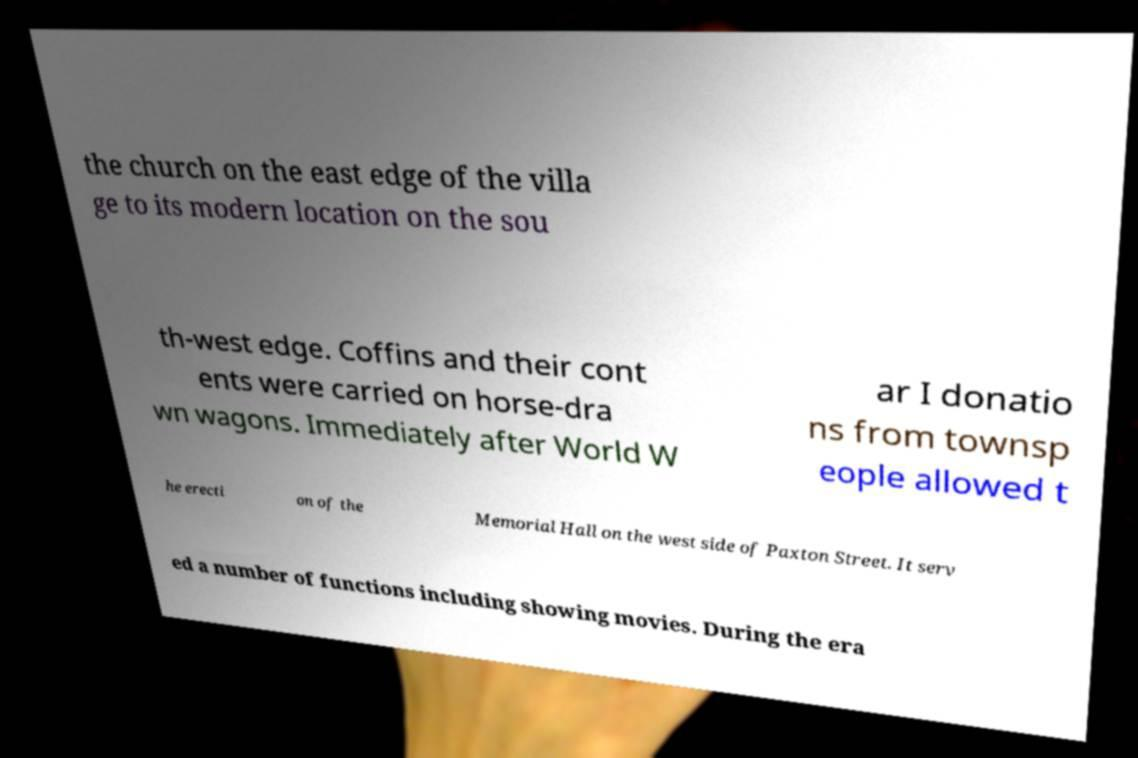Can you accurately transcribe the text from the provided image for me? the church on the east edge of the villa ge to its modern location on the sou th-west edge. Coffins and their cont ents were carried on horse-dra wn wagons. Immediately after World W ar I donatio ns from townsp eople allowed t he erecti on of the Memorial Hall on the west side of Paxton Street. It serv ed a number of functions including showing movies. During the era 